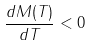<formula> <loc_0><loc_0><loc_500><loc_500>\frac { d M ( T ) } { d T } < 0</formula> 